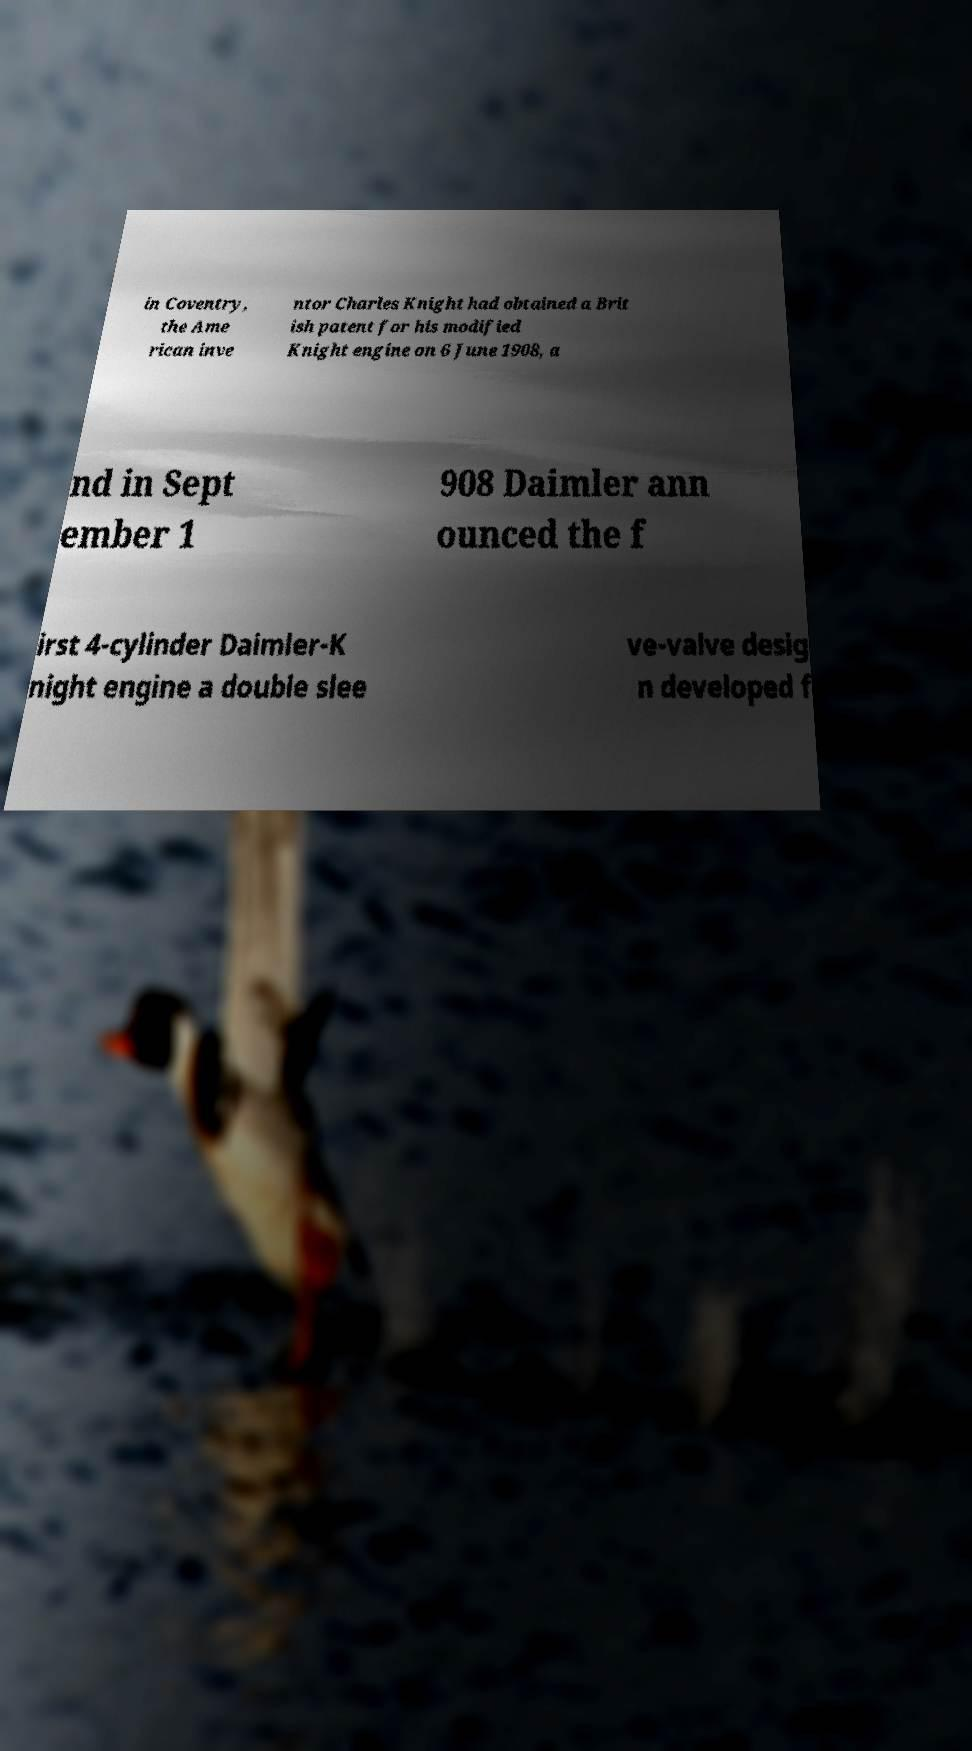Please identify and transcribe the text found in this image. in Coventry, the Ame rican inve ntor Charles Knight had obtained a Brit ish patent for his modified Knight engine on 6 June 1908, a nd in Sept ember 1 908 Daimler ann ounced the f irst 4-cylinder Daimler-K night engine a double slee ve-valve desig n developed f 